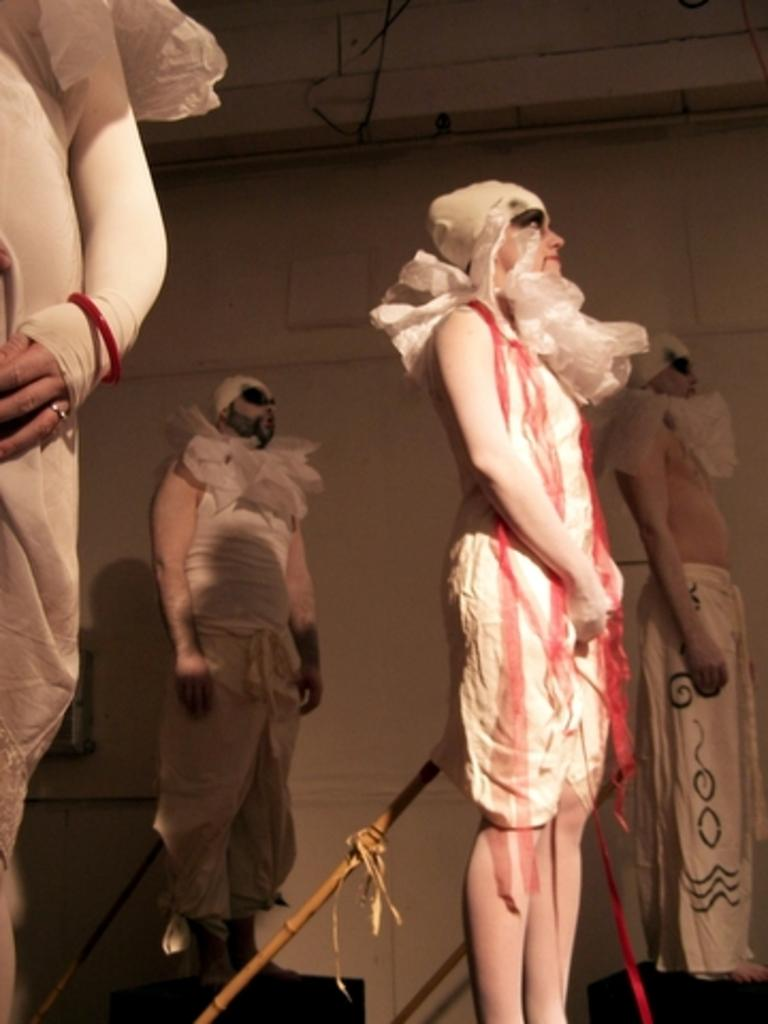How many people are in the image? There are four persons in the image. What are the persons wearing? The persons are wearing fancy dresses. Can you describe any objects in the image besides the people? Yes, there are wooden sticks in the image. What is visible in the background of the image? There is a wall in the background of the image. Can you read the receipt on the table in the image? There is no receipt present in the image. What type of blade is being used by the person in the image? There is no blade visible in the image. 